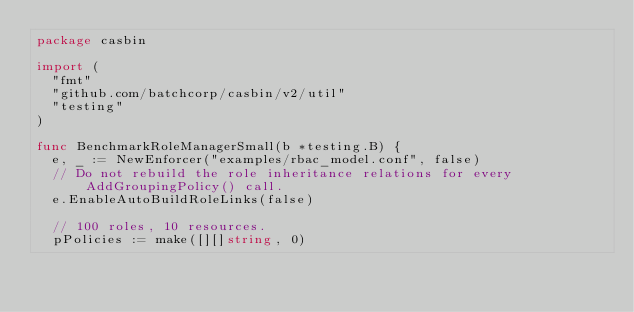Convert code to text. <code><loc_0><loc_0><loc_500><loc_500><_Go_>package casbin

import (
	"fmt"
	"github.com/batchcorp/casbin/v2/util"
	"testing"
)

func BenchmarkRoleManagerSmall(b *testing.B) {
	e, _ := NewEnforcer("examples/rbac_model.conf", false)
	// Do not rebuild the role inheritance relations for every AddGroupingPolicy() call.
	e.EnableAutoBuildRoleLinks(false)

	// 100 roles, 10 resources.
	pPolicies := make([][]string, 0)</code> 